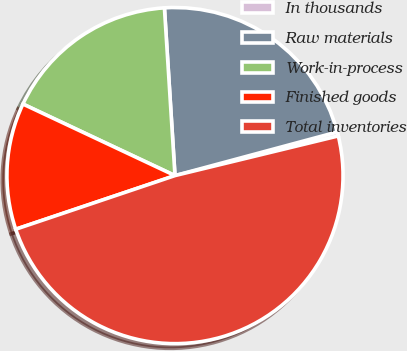Convert chart. <chart><loc_0><loc_0><loc_500><loc_500><pie_chart><fcel>In thousands<fcel>Raw materials<fcel>Work-in-process<fcel>Finished goods<fcel>Total inventories<nl><fcel>0.39%<fcel>21.82%<fcel>17.0%<fcel>12.17%<fcel>48.62%<nl></chart> 